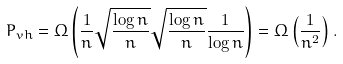<formula> <loc_0><loc_0><loc_500><loc_500>P _ { v h } = \Omega \left ( \frac { 1 } { n } \sqrt { \frac { \log n } { n } } \sqrt { \frac { \log n } { n } } \frac { 1 } { \log n } \right ) = \Omega \left ( \frac { 1 } { n ^ { 2 } } \right ) .</formula> 